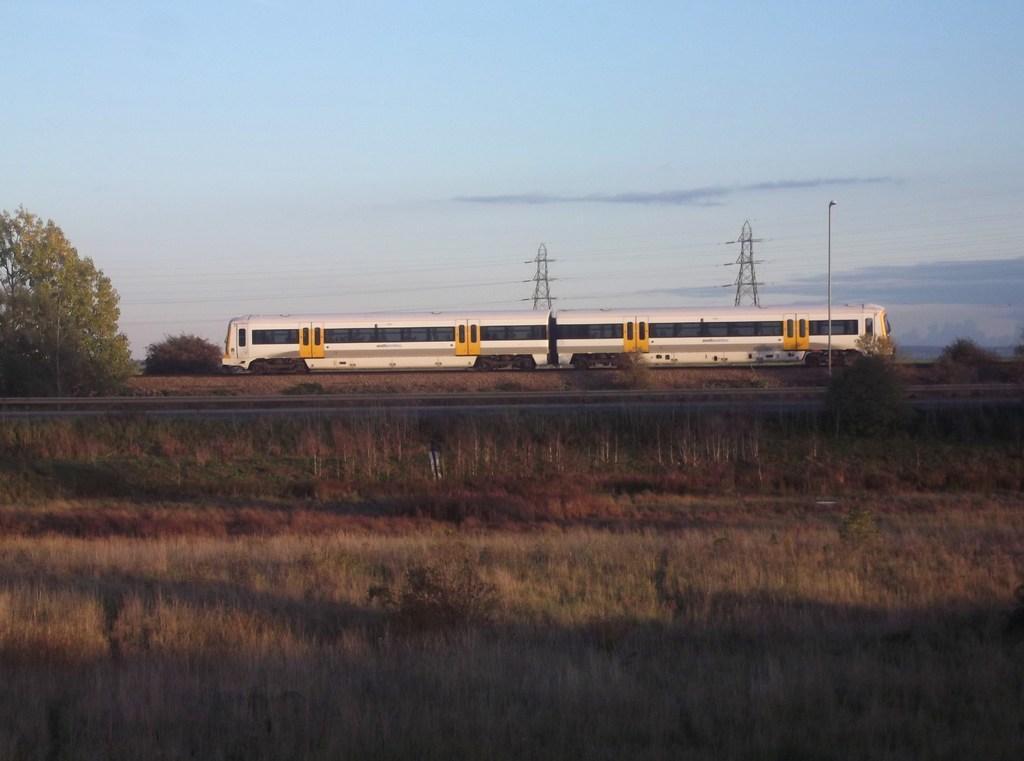How would you summarize this image in a sentence or two? In this picture we can see grass at the bottom, on the left side there are trees, we can see a train and a pole in the middle, in the background there are towers, we can see the sky at the top of the picture. 